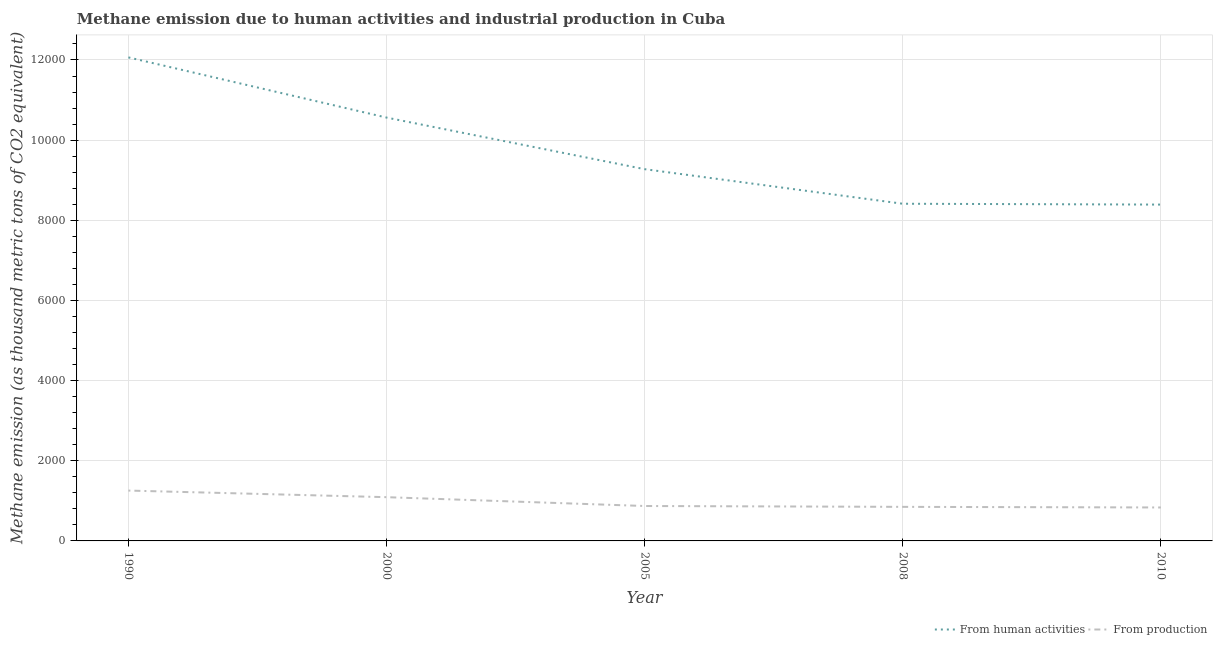How many different coloured lines are there?
Give a very brief answer. 2. Is the number of lines equal to the number of legend labels?
Your answer should be very brief. Yes. What is the amount of emissions generated from industries in 1990?
Provide a succinct answer. 1256.3. Across all years, what is the maximum amount of emissions from human activities?
Offer a terse response. 1.21e+04. Across all years, what is the minimum amount of emissions generated from industries?
Ensure brevity in your answer.  834.7. In which year was the amount of emissions from human activities maximum?
Offer a very short reply. 1990. In which year was the amount of emissions generated from industries minimum?
Your answer should be compact. 2010. What is the total amount of emissions from human activities in the graph?
Keep it short and to the point. 4.87e+04. What is the difference between the amount of emissions from human activities in 2000 and that in 2005?
Your answer should be compact. 1287.5. What is the difference between the amount of emissions generated from industries in 2000 and the amount of emissions from human activities in 2008?
Keep it short and to the point. -7321.5. What is the average amount of emissions generated from industries per year?
Your answer should be very brief. 980.78. In the year 1990, what is the difference between the amount of emissions generated from industries and amount of emissions from human activities?
Offer a terse response. -1.08e+04. In how many years, is the amount of emissions from human activities greater than 7200 thousand metric tons?
Your answer should be compact. 5. What is the ratio of the amount of emissions from human activities in 2005 to that in 2010?
Give a very brief answer. 1.11. What is the difference between the highest and the second highest amount of emissions from human activities?
Make the answer very short. 1501.9. What is the difference between the highest and the lowest amount of emissions generated from industries?
Provide a succinct answer. 421.6. In how many years, is the amount of emissions from human activities greater than the average amount of emissions from human activities taken over all years?
Provide a short and direct response. 2. Does the amount of emissions generated from industries monotonically increase over the years?
Provide a short and direct response. No. Is the amount of emissions generated from industries strictly greater than the amount of emissions from human activities over the years?
Your answer should be compact. No. How many lines are there?
Offer a terse response. 2. How many years are there in the graph?
Your answer should be very brief. 5. Are the values on the major ticks of Y-axis written in scientific E-notation?
Offer a very short reply. No. Does the graph contain any zero values?
Your answer should be very brief. No. Does the graph contain grids?
Your answer should be compact. Yes. Where does the legend appear in the graph?
Give a very brief answer. Bottom right. What is the title of the graph?
Offer a very short reply. Methane emission due to human activities and industrial production in Cuba. What is the label or title of the X-axis?
Offer a very short reply. Year. What is the label or title of the Y-axis?
Provide a short and direct response. Methane emission (as thousand metric tons of CO2 equivalent). What is the Methane emission (as thousand metric tons of CO2 equivalent) in From human activities in 1990?
Keep it short and to the point. 1.21e+04. What is the Methane emission (as thousand metric tons of CO2 equivalent) in From production in 1990?
Offer a terse response. 1256.3. What is the Methane emission (as thousand metric tons of CO2 equivalent) in From human activities in 2000?
Make the answer very short. 1.06e+04. What is the Methane emission (as thousand metric tons of CO2 equivalent) of From production in 2000?
Ensure brevity in your answer.  1091.6. What is the Methane emission (as thousand metric tons of CO2 equivalent) in From human activities in 2005?
Offer a very short reply. 9275.8. What is the Methane emission (as thousand metric tons of CO2 equivalent) in From production in 2005?
Your answer should be compact. 871.3. What is the Methane emission (as thousand metric tons of CO2 equivalent) in From human activities in 2008?
Give a very brief answer. 8413.1. What is the Methane emission (as thousand metric tons of CO2 equivalent) of From production in 2008?
Keep it short and to the point. 850. What is the Methane emission (as thousand metric tons of CO2 equivalent) of From human activities in 2010?
Your answer should be compact. 8392.1. What is the Methane emission (as thousand metric tons of CO2 equivalent) of From production in 2010?
Ensure brevity in your answer.  834.7. Across all years, what is the maximum Methane emission (as thousand metric tons of CO2 equivalent) in From human activities?
Provide a short and direct response. 1.21e+04. Across all years, what is the maximum Methane emission (as thousand metric tons of CO2 equivalent) of From production?
Your answer should be compact. 1256.3. Across all years, what is the minimum Methane emission (as thousand metric tons of CO2 equivalent) in From human activities?
Keep it short and to the point. 8392.1. Across all years, what is the minimum Methane emission (as thousand metric tons of CO2 equivalent) in From production?
Keep it short and to the point. 834.7. What is the total Methane emission (as thousand metric tons of CO2 equivalent) in From human activities in the graph?
Keep it short and to the point. 4.87e+04. What is the total Methane emission (as thousand metric tons of CO2 equivalent) of From production in the graph?
Provide a short and direct response. 4903.9. What is the difference between the Methane emission (as thousand metric tons of CO2 equivalent) of From human activities in 1990 and that in 2000?
Provide a succinct answer. 1501.9. What is the difference between the Methane emission (as thousand metric tons of CO2 equivalent) in From production in 1990 and that in 2000?
Your answer should be very brief. 164.7. What is the difference between the Methane emission (as thousand metric tons of CO2 equivalent) in From human activities in 1990 and that in 2005?
Keep it short and to the point. 2789.4. What is the difference between the Methane emission (as thousand metric tons of CO2 equivalent) of From production in 1990 and that in 2005?
Ensure brevity in your answer.  385. What is the difference between the Methane emission (as thousand metric tons of CO2 equivalent) in From human activities in 1990 and that in 2008?
Provide a short and direct response. 3652.1. What is the difference between the Methane emission (as thousand metric tons of CO2 equivalent) in From production in 1990 and that in 2008?
Your answer should be very brief. 406.3. What is the difference between the Methane emission (as thousand metric tons of CO2 equivalent) in From human activities in 1990 and that in 2010?
Make the answer very short. 3673.1. What is the difference between the Methane emission (as thousand metric tons of CO2 equivalent) of From production in 1990 and that in 2010?
Provide a succinct answer. 421.6. What is the difference between the Methane emission (as thousand metric tons of CO2 equivalent) in From human activities in 2000 and that in 2005?
Your response must be concise. 1287.5. What is the difference between the Methane emission (as thousand metric tons of CO2 equivalent) in From production in 2000 and that in 2005?
Offer a terse response. 220.3. What is the difference between the Methane emission (as thousand metric tons of CO2 equivalent) in From human activities in 2000 and that in 2008?
Make the answer very short. 2150.2. What is the difference between the Methane emission (as thousand metric tons of CO2 equivalent) of From production in 2000 and that in 2008?
Ensure brevity in your answer.  241.6. What is the difference between the Methane emission (as thousand metric tons of CO2 equivalent) of From human activities in 2000 and that in 2010?
Your response must be concise. 2171.2. What is the difference between the Methane emission (as thousand metric tons of CO2 equivalent) in From production in 2000 and that in 2010?
Keep it short and to the point. 256.9. What is the difference between the Methane emission (as thousand metric tons of CO2 equivalent) of From human activities in 2005 and that in 2008?
Offer a very short reply. 862.7. What is the difference between the Methane emission (as thousand metric tons of CO2 equivalent) in From production in 2005 and that in 2008?
Give a very brief answer. 21.3. What is the difference between the Methane emission (as thousand metric tons of CO2 equivalent) of From human activities in 2005 and that in 2010?
Your response must be concise. 883.7. What is the difference between the Methane emission (as thousand metric tons of CO2 equivalent) of From production in 2005 and that in 2010?
Give a very brief answer. 36.6. What is the difference between the Methane emission (as thousand metric tons of CO2 equivalent) of From human activities in 2008 and that in 2010?
Your answer should be very brief. 21. What is the difference between the Methane emission (as thousand metric tons of CO2 equivalent) in From human activities in 1990 and the Methane emission (as thousand metric tons of CO2 equivalent) in From production in 2000?
Offer a very short reply. 1.10e+04. What is the difference between the Methane emission (as thousand metric tons of CO2 equivalent) of From human activities in 1990 and the Methane emission (as thousand metric tons of CO2 equivalent) of From production in 2005?
Ensure brevity in your answer.  1.12e+04. What is the difference between the Methane emission (as thousand metric tons of CO2 equivalent) in From human activities in 1990 and the Methane emission (as thousand metric tons of CO2 equivalent) in From production in 2008?
Your answer should be very brief. 1.12e+04. What is the difference between the Methane emission (as thousand metric tons of CO2 equivalent) of From human activities in 1990 and the Methane emission (as thousand metric tons of CO2 equivalent) of From production in 2010?
Your answer should be compact. 1.12e+04. What is the difference between the Methane emission (as thousand metric tons of CO2 equivalent) in From human activities in 2000 and the Methane emission (as thousand metric tons of CO2 equivalent) in From production in 2005?
Give a very brief answer. 9692. What is the difference between the Methane emission (as thousand metric tons of CO2 equivalent) of From human activities in 2000 and the Methane emission (as thousand metric tons of CO2 equivalent) of From production in 2008?
Offer a terse response. 9713.3. What is the difference between the Methane emission (as thousand metric tons of CO2 equivalent) of From human activities in 2000 and the Methane emission (as thousand metric tons of CO2 equivalent) of From production in 2010?
Provide a short and direct response. 9728.6. What is the difference between the Methane emission (as thousand metric tons of CO2 equivalent) of From human activities in 2005 and the Methane emission (as thousand metric tons of CO2 equivalent) of From production in 2008?
Your answer should be compact. 8425.8. What is the difference between the Methane emission (as thousand metric tons of CO2 equivalent) of From human activities in 2005 and the Methane emission (as thousand metric tons of CO2 equivalent) of From production in 2010?
Your response must be concise. 8441.1. What is the difference between the Methane emission (as thousand metric tons of CO2 equivalent) in From human activities in 2008 and the Methane emission (as thousand metric tons of CO2 equivalent) in From production in 2010?
Provide a short and direct response. 7578.4. What is the average Methane emission (as thousand metric tons of CO2 equivalent) in From human activities per year?
Offer a terse response. 9741.9. What is the average Methane emission (as thousand metric tons of CO2 equivalent) in From production per year?
Offer a terse response. 980.78. In the year 1990, what is the difference between the Methane emission (as thousand metric tons of CO2 equivalent) in From human activities and Methane emission (as thousand metric tons of CO2 equivalent) in From production?
Your answer should be compact. 1.08e+04. In the year 2000, what is the difference between the Methane emission (as thousand metric tons of CO2 equivalent) of From human activities and Methane emission (as thousand metric tons of CO2 equivalent) of From production?
Keep it short and to the point. 9471.7. In the year 2005, what is the difference between the Methane emission (as thousand metric tons of CO2 equivalent) of From human activities and Methane emission (as thousand metric tons of CO2 equivalent) of From production?
Make the answer very short. 8404.5. In the year 2008, what is the difference between the Methane emission (as thousand metric tons of CO2 equivalent) in From human activities and Methane emission (as thousand metric tons of CO2 equivalent) in From production?
Your response must be concise. 7563.1. In the year 2010, what is the difference between the Methane emission (as thousand metric tons of CO2 equivalent) of From human activities and Methane emission (as thousand metric tons of CO2 equivalent) of From production?
Your response must be concise. 7557.4. What is the ratio of the Methane emission (as thousand metric tons of CO2 equivalent) in From human activities in 1990 to that in 2000?
Offer a terse response. 1.14. What is the ratio of the Methane emission (as thousand metric tons of CO2 equivalent) in From production in 1990 to that in 2000?
Give a very brief answer. 1.15. What is the ratio of the Methane emission (as thousand metric tons of CO2 equivalent) of From human activities in 1990 to that in 2005?
Your answer should be very brief. 1.3. What is the ratio of the Methane emission (as thousand metric tons of CO2 equivalent) in From production in 1990 to that in 2005?
Provide a succinct answer. 1.44. What is the ratio of the Methane emission (as thousand metric tons of CO2 equivalent) in From human activities in 1990 to that in 2008?
Offer a terse response. 1.43. What is the ratio of the Methane emission (as thousand metric tons of CO2 equivalent) in From production in 1990 to that in 2008?
Provide a succinct answer. 1.48. What is the ratio of the Methane emission (as thousand metric tons of CO2 equivalent) of From human activities in 1990 to that in 2010?
Your answer should be very brief. 1.44. What is the ratio of the Methane emission (as thousand metric tons of CO2 equivalent) in From production in 1990 to that in 2010?
Your answer should be very brief. 1.51. What is the ratio of the Methane emission (as thousand metric tons of CO2 equivalent) in From human activities in 2000 to that in 2005?
Provide a succinct answer. 1.14. What is the ratio of the Methane emission (as thousand metric tons of CO2 equivalent) in From production in 2000 to that in 2005?
Ensure brevity in your answer.  1.25. What is the ratio of the Methane emission (as thousand metric tons of CO2 equivalent) in From human activities in 2000 to that in 2008?
Offer a very short reply. 1.26. What is the ratio of the Methane emission (as thousand metric tons of CO2 equivalent) in From production in 2000 to that in 2008?
Your answer should be very brief. 1.28. What is the ratio of the Methane emission (as thousand metric tons of CO2 equivalent) of From human activities in 2000 to that in 2010?
Your response must be concise. 1.26. What is the ratio of the Methane emission (as thousand metric tons of CO2 equivalent) of From production in 2000 to that in 2010?
Your answer should be very brief. 1.31. What is the ratio of the Methane emission (as thousand metric tons of CO2 equivalent) in From human activities in 2005 to that in 2008?
Your response must be concise. 1.1. What is the ratio of the Methane emission (as thousand metric tons of CO2 equivalent) of From production in 2005 to that in 2008?
Keep it short and to the point. 1.03. What is the ratio of the Methane emission (as thousand metric tons of CO2 equivalent) in From human activities in 2005 to that in 2010?
Your answer should be compact. 1.11. What is the ratio of the Methane emission (as thousand metric tons of CO2 equivalent) in From production in 2005 to that in 2010?
Offer a very short reply. 1.04. What is the ratio of the Methane emission (as thousand metric tons of CO2 equivalent) in From production in 2008 to that in 2010?
Your answer should be compact. 1.02. What is the difference between the highest and the second highest Methane emission (as thousand metric tons of CO2 equivalent) in From human activities?
Your response must be concise. 1501.9. What is the difference between the highest and the second highest Methane emission (as thousand metric tons of CO2 equivalent) of From production?
Offer a terse response. 164.7. What is the difference between the highest and the lowest Methane emission (as thousand metric tons of CO2 equivalent) of From human activities?
Your answer should be compact. 3673.1. What is the difference between the highest and the lowest Methane emission (as thousand metric tons of CO2 equivalent) of From production?
Your answer should be very brief. 421.6. 